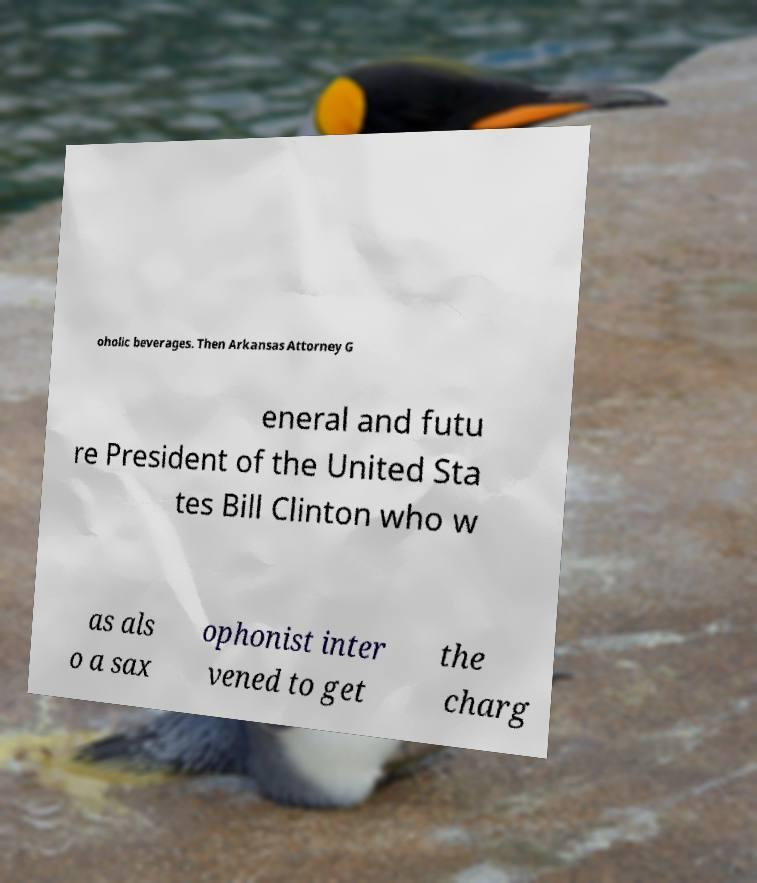There's text embedded in this image that I need extracted. Can you transcribe it verbatim? oholic beverages. Then Arkansas Attorney G eneral and futu re President of the United Sta tes Bill Clinton who w as als o a sax ophonist inter vened to get the charg 